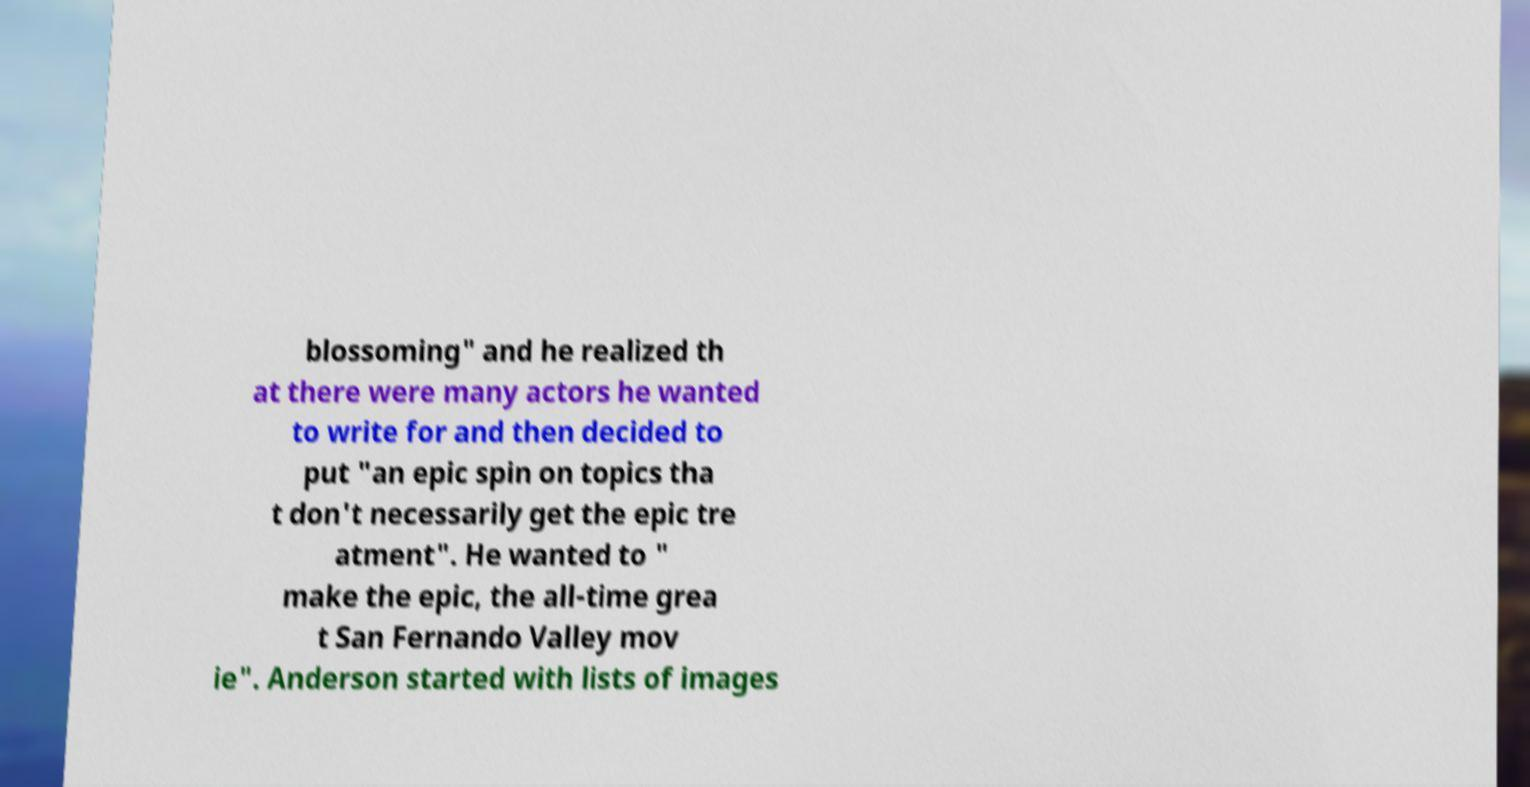Please identify and transcribe the text found in this image. blossoming" and he realized th at there were many actors he wanted to write for and then decided to put "an epic spin on topics tha t don't necessarily get the epic tre atment". He wanted to " make the epic, the all-time grea t San Fernando Valley mov ie". Anderson started with lists of images 